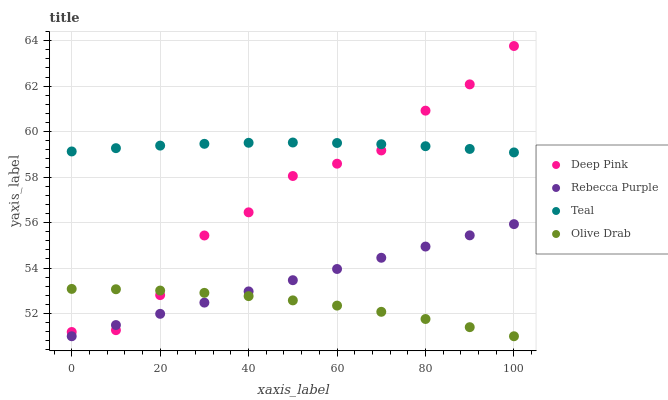Does Olive Drab have the minimum area under the curve?
Answer yes or no. Yes. Does Teal have the maximum area under the curve?
Answer yes or no. Yes. Does Deep Pink have the minimum area under the curve?
Answer yes or no. No. Does Deep Pink have the maximum area under the curve?
Answer yes or no. No. Is Rebecca Purple the smoothest?
Answer yes or no. Yes. Is Deep Pink the roughest?
Answer yes or no. Yes. Is Deep Pink the smoothest?
Answer yes or no. No. Is Rebecca Purple the roughest?
Answer yes or no. No. Does Olive Drab have the lowest value?
Answer yes or no. Yes. Does Deep Pink have the lowest value?
Answer yes or no. No. Does Deep Pink have the highest value?
Answer yes or no. Yes. Does Rebecca Purple have the highest value?
Answer yes or no. No. Is Olive Drab less than Teal?
Answer yes or no. Yes. Is Teal greater than Olive Drab?
Answer yes or no. Yes. Does Deep Pink intersect Olive Drab?
Answer yes or no. Yes. Is Deep Pink less than Olive Drab?
Answer yes or no. No. Is Deep Pink greater than Olive Drab?
Answer yes or no. No. Does Olive Drab intersect Teal?
Answer yes or no. No. 